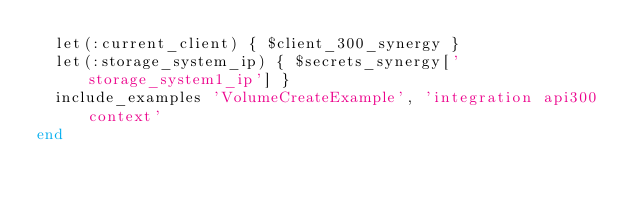<code> <loc_0><loc_0><loc_500><loc_500><_Ruby_>  let(:current_client) { $client_300_synergy }
  let(:storage_system_ip) { $secrets_synergy['storage_system1_ip'] }
  include_examples 'VolumeCreateExample', 'integration api300 context'
end
</code> 